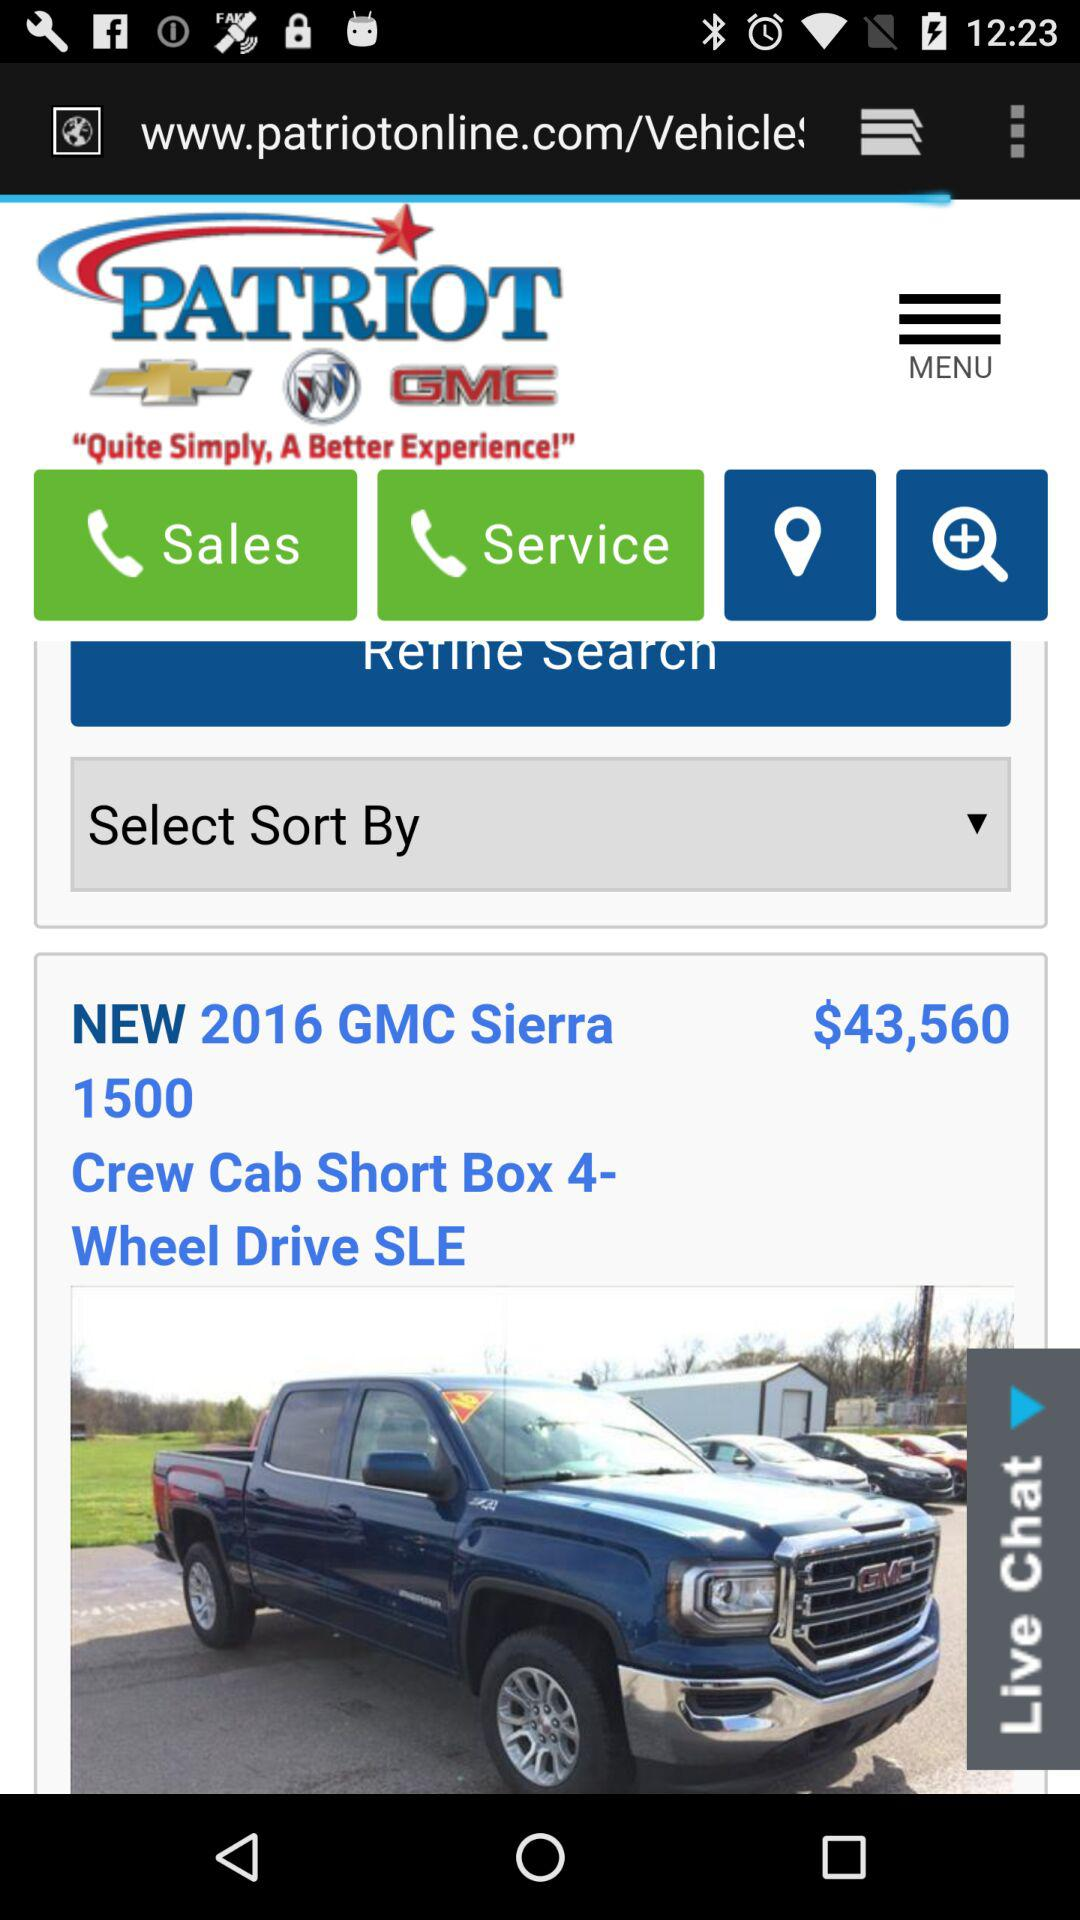What is the type of chat? This is live chat. 